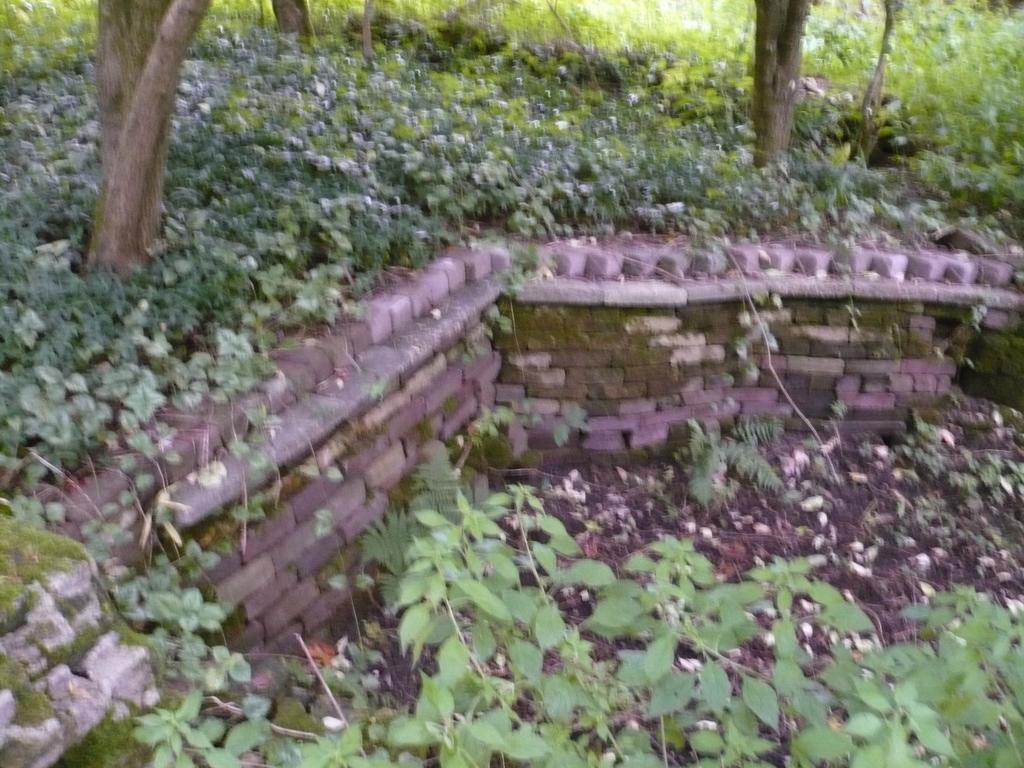Can you describe this image briefly? There is a small wall and there are many small bushes and some tall trees above the wall and below the wall there are some plants and soil. 